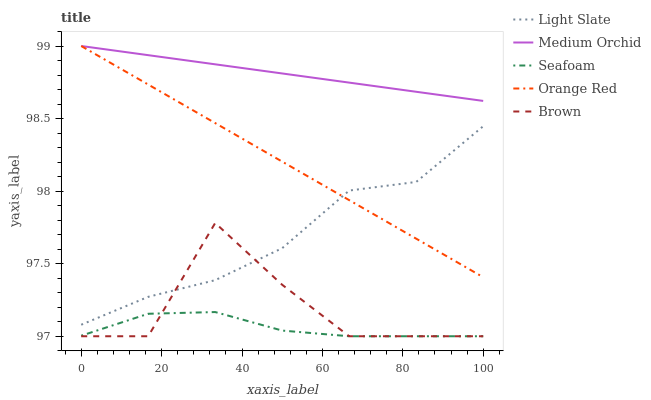Does Seafoam have the minimum area under the curve?
Answer yes or no. Yes. Does Medium Orchid have the maximum area under the curve?
Answer yes or no. Yes. Does Brown have the minimum area under the curve?
Answer yes or no. No. Does Brown have the maximum area under the curve?
Answer yes or no. No. Is Medium Orchid the smoothest?
Answer yes or no. Yes. Is Brown the roughest?
Answer yes or no. Yes. Is Brown the smoothest?
Answer yes or no. No. Is Medium Orchid the roughest?
Answer yes or no. No. Does Brown have the lowest value?
Answer yes or no. Yes. Does Medium Orchid have the lowest value?
Answer yes or no. No. Does Orange Red have the highest value?
Answer yes or no. Yes. Does Brown have the highest value?
Answer yes or no. No. Is Brown less than Medium Orchid?
Answer yes or no. Yes. Is Light Slate greater than Seafoam?
Answer yes or no. Yes. Does Orange Red intersect Light Slate?
Answer yes or no. Yes. Is Orange Red less than Light Slate?
Answer yes or no. No. Is Orange Red greater than Light Slate?
Answer yes or no. No. Does Brown intersect Medium Orchid?
Answer yes or no. No. 